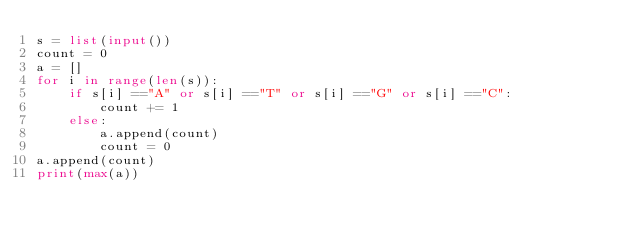<code> <loc_0><loc_0><loc_500><loc_500><_Python_>s = list(input())
count = 0
a = []
for i in range(len(s)):
    if s[i] =="A" or s[i] =="T" or s[i] =="G" or s[i] =="C":
        count += 1
    else:
        a.append(count)
        count = 0
a.append(count)
print(max(a))</code> 